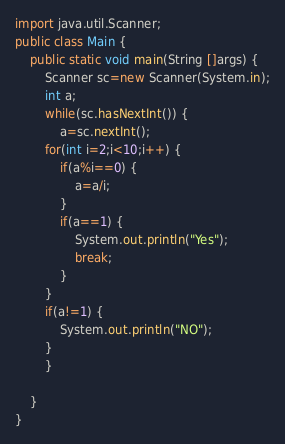Convert code to text. <code><loc_0><loc_0><loc_500><loc_500><_Java_>import java.util.Scanner;
public class Main {
	public static void main(String []args) {
		Scanner sc=new Scanner(System.in);
		int a;
		while(sc.hasNextInt()) {
			a=sc.nextInt();
		for(int i=2;i<10;i++) {
			if(a%i==0) {
				a=a/i;
			}
			if(a==1) {
				System.out.println("Yes");
				break;
			}
		}
		if(a!=1) {
			System.out.println("NO");
		}
		}
		
	}
}
</code> 